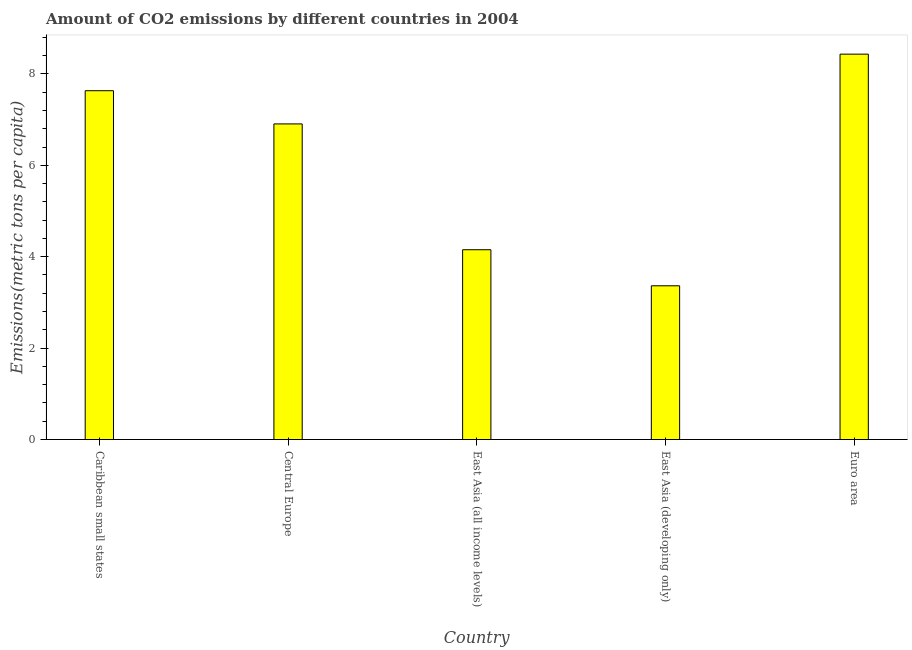Does the graph contain any zero values?
Offer a very short reply. No. What is the title of the graph?
Offer a terse response. Amount of CO2 emissions by different countries in 2004. What is the label or title of the Y-axis?
Provide a succinct answer. Emissions(metric tons per capita). What is the amount of co2 emissions in Euro area?
Offer a very short reply. 8.43. Across all countries, what is the maximum amount of co2 emissions?
Your answer should be compact. 8.43. Across all countries, what is the minimum amount of co2 emissions?
Your answer should be compact. 3.36. In which country was the amount of co2 emissions minimum?
Your answer should be compact. East Asia (developing only). What is the sum of the amount of co2 emissions?
Your answer should be compact. 30.49. What is the difference between the amount of co2 emissions in East Asia (developing only) and Euro area?
Provide a succinct answer. -5.07. What is the average amount of co2 emissions per country?
Ensure brevity in your answer.  6.1. What is the median amount of co2 emissions?
Ensure brevity in your answer.  6.91. What is the ratio of the amount of co2 emissions in Caribbean small states to that in Euro area?
Provide a succinct answer. 0.91. Is the difference between the amount of co2 emissions in Central Europe and Euro area greater than the difference between any two countries?
Make the answer very short. No. Is the sum of the amount of co2 emissions in Caribbean small states and Euro area greater than the maximum amount of co2 emissions across all countries?
Give a very brief answer. Yes. What is the difference between the highest and the lowest amount of co2 emissions?
Your answer should be very brief. 5.07. What is the Emissions(metric tons per capita) of Caribbean small states?
Your answer should be very brief. 7.63. What is the Emissions(metric tons per capita) in Central Europe?
Provide a short and direct response. 6.91. What is the Emissions(metric tons per capita) of East Asia (all income levels)?
Offer a terse response. 4.15. What is the Emissions(metric tons per capita) of East Asia (developing only)?
Give a very brief answer. 3.36. What is the Emissions(metric tons per capita) in Euro area?
Your response must be concise. 8.43. What is the difference between the Emissions(metric tons per capita) in Caribbean small states and Central Europe?
Keep it short and to the point. 0.73. What is the difference between the Emissions(metric tons per capita) in Caribbean small states and East Asia (all income levels)?
Offer a terse response. 3.48. What is the difference between the Emissions(metric tons per capita) in Caribbean small states and East Asia (developing only)?
Provide a short and direct response. 4.27. What is the difference between the Emissions(metric tons per capita) in Caribbean small states and Euro area?
Your answer should be very brief. -0.8. What is the difference between the Emissions(metric tons per capita) in Central Europe and East Asia (all income levels)?
Ensure brevity in your answer.  2.75. What is the difference between the Emissions(metric tons per capita) in Central Europe and East Asia (developing only)?
Make the answer very short. 3.54. What is the difference between the Emissions(metric tons per capita) in Central Europe and Euro area?
Keep it short and to the point. -1.53. What is the difference between the Emissions(metric tons per capita) in East Asia (all income levels) and East Asia (developing only)?
Provide a short and direct response. 0.79. What is the difference between the Emissions(metric tons per capita) in East Asia (all income levels) and Euro area?
Provide a short and direct response. -4.28. What is the difference between the Emissions(metric tons per capita) in East Asia (developing only) and Euro area?
Your answer should be very brief. -5.07. What is the ratio of the Emissions(metric tons per capita) in Caribbean small states to that in Central Europe?
Give a very brief answer. 1.1. What is the ratio of the Emissions(metric tons per capita) in Caribbean small states to that in East Asia (all income levels)?
Your answer should be compact. 1.84. What is the ratio of the Emissions(metric tons per capita) in Caribbean small states to that in East Asia (developing only)?
Give a very brief answer. 2.27. What is the ratio of the Emissions(metric tons per capita) in Caribbean small states to that in Euro area?
Ensure brevity in your answer.  0.91. What is the ratio of the Emissions(metric tons per capita) in Central Europe to that in East Asia (all income levels)?
Make the answer very short. 1.66. What is the ratio of the Emissions(metric tons per capita) in Central Europe to that in East Asia (developing only)?
Make the answer very short. 2.05. What is the ratio of the Emissions(metric tons per capita) in Central Europe to that in Euro area?
Offer a very short reply. 0.82. What is the ratio of the Emissions(metric tons per capita) in East Asia (all income levels) to that in East Asia (developing only)?
Make the answer very short. 1.24. What is the ratio of the Emissions(metric tons per capita) in East Asia (all income levels) to that in Euro area?
Provide a short and direct response. 0.49. What is the ratio of the Emissions(metric tons per capita) in East Asia (developing only) to that in Euro area?
Keep it short and to the point. 0.4. 